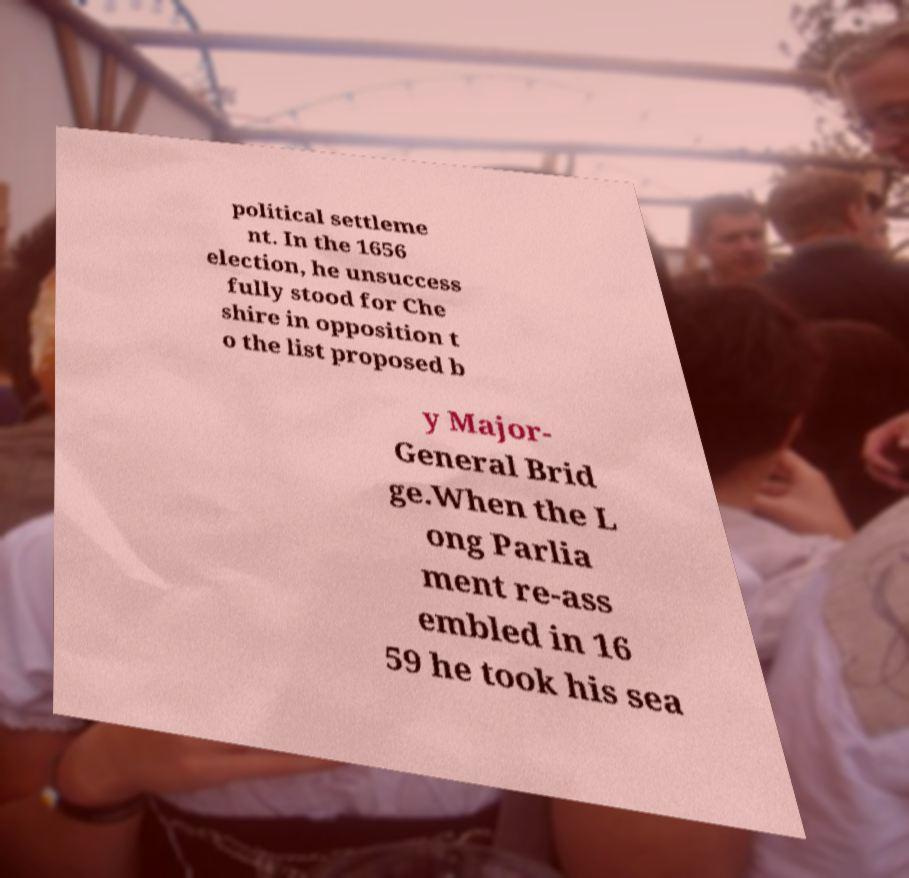What messages or text are displayed in this image? I need them in a readable, typed format. political settleme nt. In the 1656 election, he unsuccess fully stood for Che shire in opposition t o the list proposed b y Major- General Brid ge.When the L ong Parlia ment re-ass embled in 16 59 he took his sea 